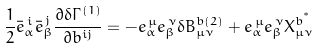<formula> <loc_0><loc_0><loc_500><loc_500>\frac { 1 } { 2 } { \bar { e } } _ { \alpha } ^ { \, i } { \bar { e } } _ { \beta } ^ { \, j } \frac { \partial \delta \Gamma ^ { ( 1 ) } } { \partial b ^ { i j } } = - e _ { \alpha } ^ { \, \mu } e _ { \beta } ^ { \, \nu } \delta B ^ { b ( 2 ) } _ { \mu \nu } + e _ { \alpha } ^ { \, \mu } e _ { \beta } ^ { \, \nu } X ^ { b ^ { ^ { * } } } _ { \mu \nu }</formula> 